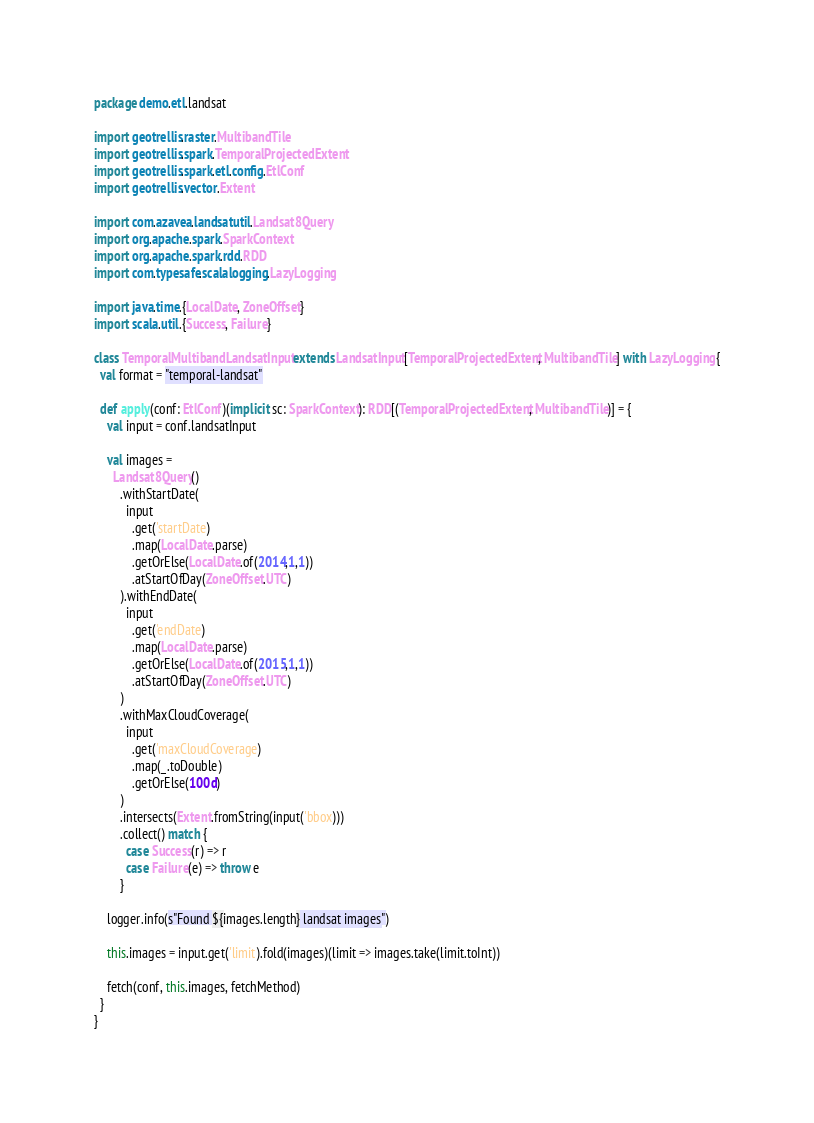Convert code to text. <code><loc_0><loc_0><loc_500><loc_500><_Scala_>package demo.etl.landsat

import geotrellis.raster.MultibandTile
import geotrellis.spark.TemporalProjectedExtent
import geotrellis.spark.etl.config.EtlConf
import geotrellis.vector.Extent

import com.azavea.landsatutil.Landsat8Query
import org.apache.spark.SparkContext
import org.apache.spark.rdd.RDD
import com.typesafe.scalalogging.LazyLogging

import java.time.{LocalDate, ZoneOffset}
import scala.util.{Success, Failure}

class TemporalMultibandLandsatInput extends LandsatInput[TemporalProjectedExtent, MultibandTile] with LazyLogging {
  val format = "temporal-landsat"

  def apply(conf: EtlConf)(implicit sc: SparkContext): RDD[(TemporalProjectedExtent, MultibandTile)] = {
    val input = conf.landsatInput

    val images =
      Landsat8Query()
        .withStartDate(
          input
            .get('startDate)
            .map(LocalDate.parse)
            .getOrElse(LocalDate.of(2014,1,1))
            .atStartOfDay(ZoneOffset.UTC)
        ).withEndDate(
          input
            .get('endDate)
            .map(LocalDate.parse)
            .getOrElse(LocalDate.of(2015,1,1))
            .atStartOfDay(ZoneOffset.UTC)
        )
        .withMaxCloudCoverage(
          input
            .get('maxCloudCoverage)
            .map(_.toDouble)
            .getOrElse(100d)
        )
        .intersects(Extent.fromString(input('bbox)))
        .collect() match {
          case Success(r) => r
          case Failure(e) => throw e
        }

    logger.info(s"Found ${images.length} landsat images")

    this.images = input.get('limit).fold(images)(limit => images.take(limit.toInt))

    fetch(conf, this.images, fetchMethod)
  }
}
</code> 